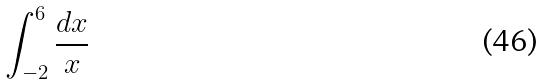<formula> <loc_0><loc_0><loc_500><loc_500>\int _ { - 2 } ^ { 6 } \frac { d x } { x }</formula> 